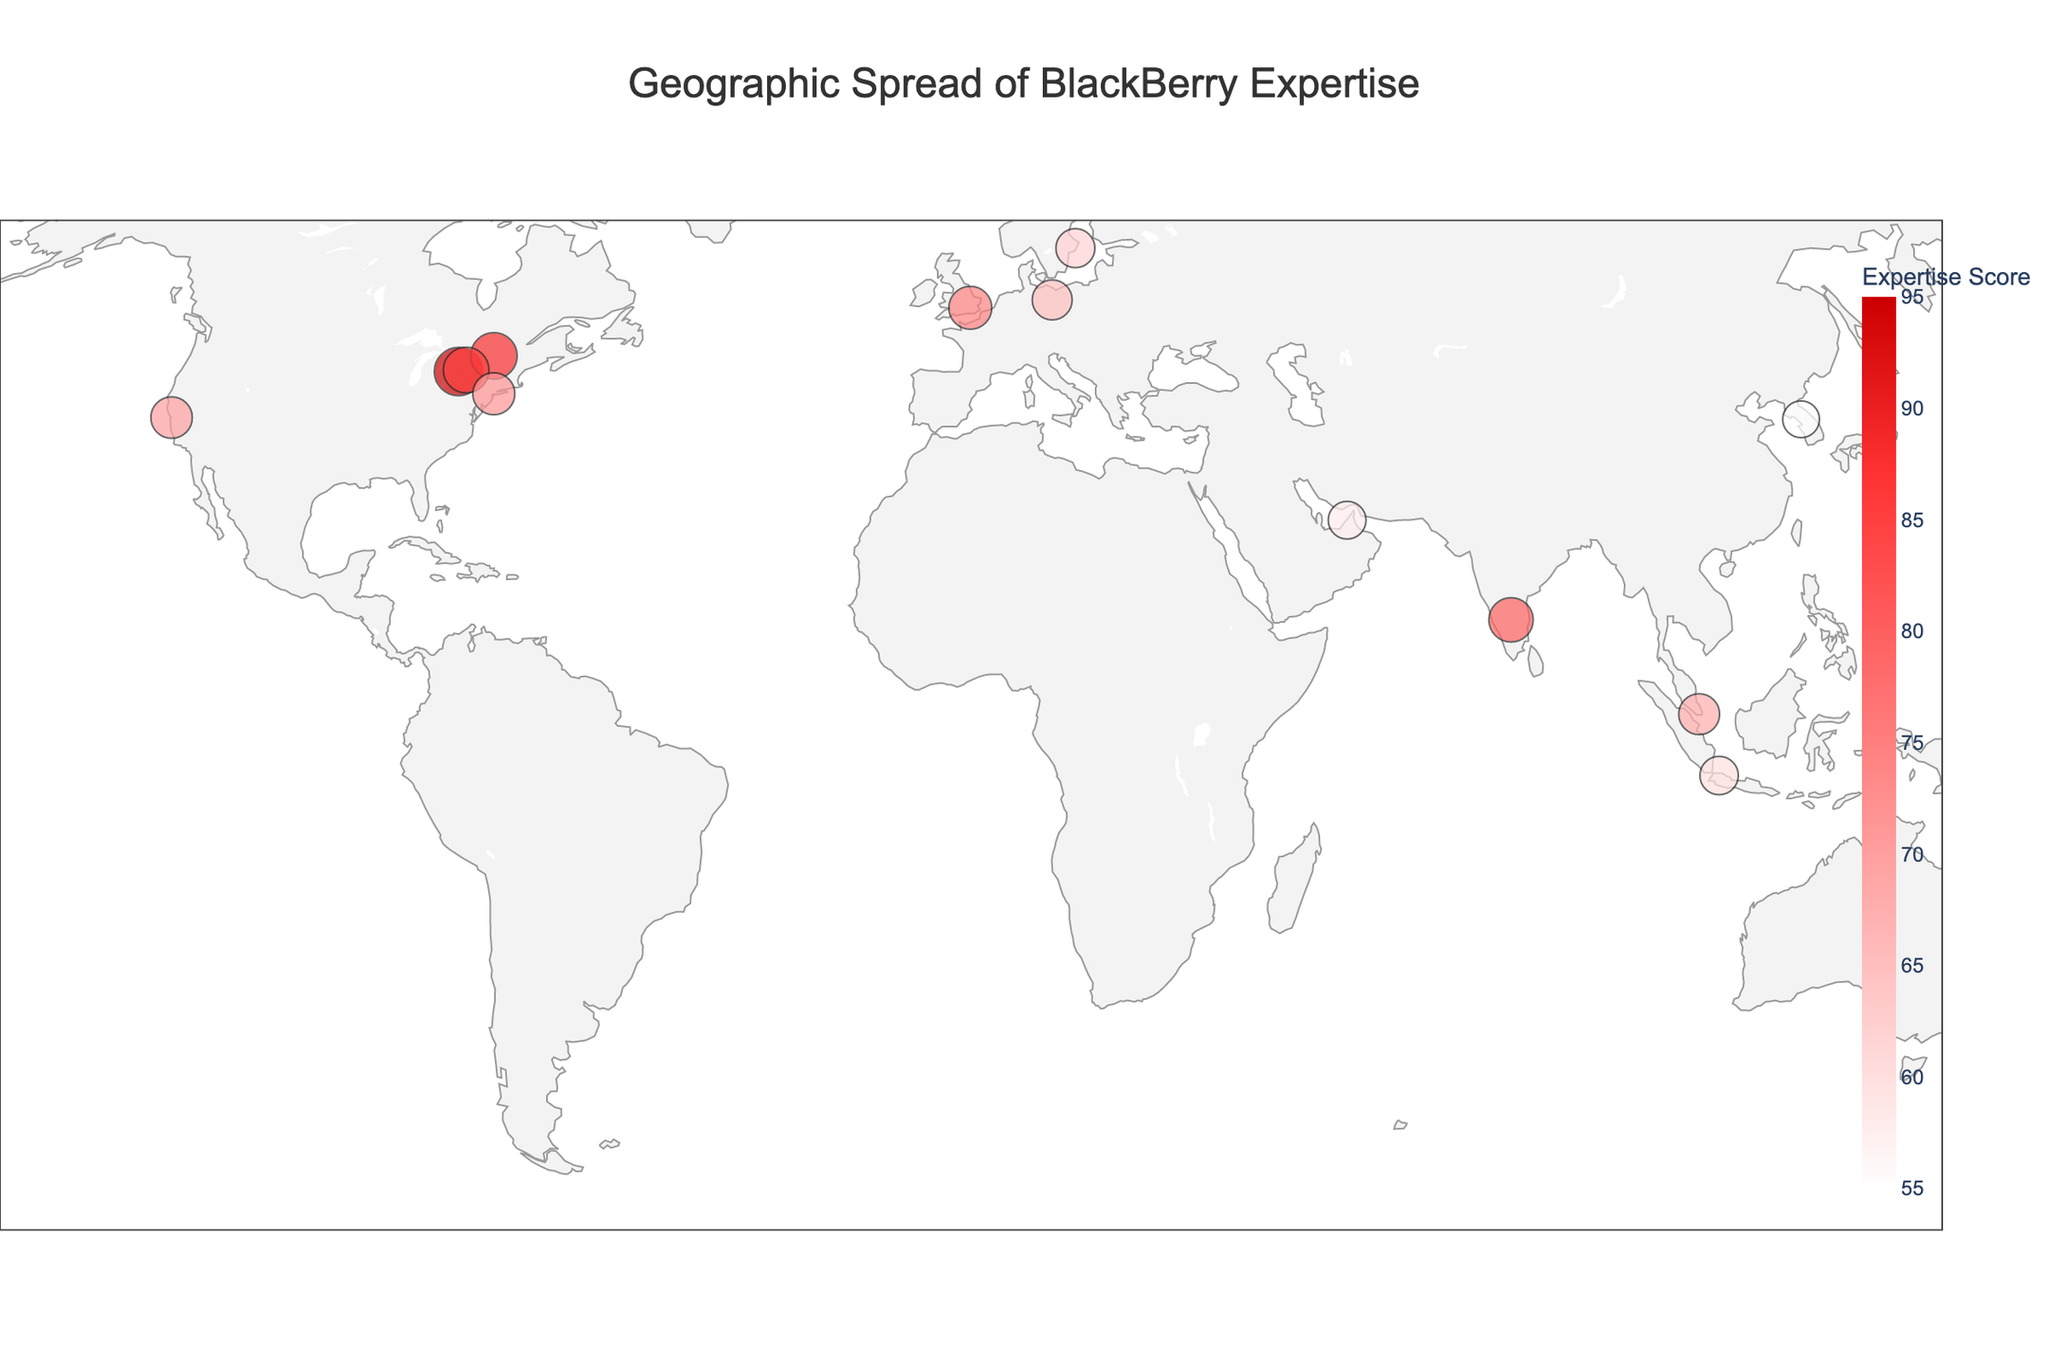What's the title of the figure? The title of the figure is displayed at the top of the plot with larger font size. It reads "Geographic Spread of BlackBerry Expertise".
Answer: Geographic Spread of BlackBerry Expertise How many cities have a BlackBerry expertise score greater than 70? To find the number of cities with a score greater than 70, observe the size and color of circles on the plot. The cities with darker red circles and larger sizes meet the criteria.
Answer: 5 Which city has the highest BlackBerry expertise score? Locate the city that has the largest circle and darkest red color, which corresponds to the highest expertise score in the plot.
Answer: Waterloo What is the average BlackBerry expertise score of all cities displayed? Add up all the expertise scores and divide by the number of cities: (95+88+85+80+75+72+70+68+65+62+60+58+55) / 13.
Answer: 71.77 Which city in the United States has a higher BlackBerry expertise score, New York City or San Francisco? Compare the sizes and colors of the circles representing New York City and San Francisco. The city with the larger circle and darker color has the higher score.
Answer: New York City What is the difference in expertise score between London, UK, and Berlin, Germany? Subtract the expertise score of Berlin from that of London: 75 - 65.
Answer: 10 Identify two cities from different continents with the closest BlackBerry expertise scores. Scan the plot for pairs of cities with similar circle sizes and colors, ensuring they are on different continents. San Francisco (70) and Singapore (68) meet this criterion.
Answer: San Francisco and Singapore Which continent has the most cities with a BlackBerry expertise score above 60? Count the number of circles with scores above 60 for each continent: North America has multiple cities with high scores, specifically Waterloo, Ottawa, and Toronto.
Answer: North America Is the BlackBerry expertise score of Toronto higher or lower than that of Bangalore? Look at the circles for Toronto and Bangalore; compare their sizes and colors. Toronto's is larger and darker red than Bangalore's.
Answer: Higher Considering the highest and lowest BlackBerry expertise scores in the figure, what is the range of scores? Subtract the lowest expertise score (55 for Seoul) from the highest expertise score (95 for Waterloo): 95 - 55.
Answer: 40 